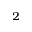Convert formula to latex. <formula><loc_0><loc_0><loc_500><loc_500>_ { 2 }</formula> 